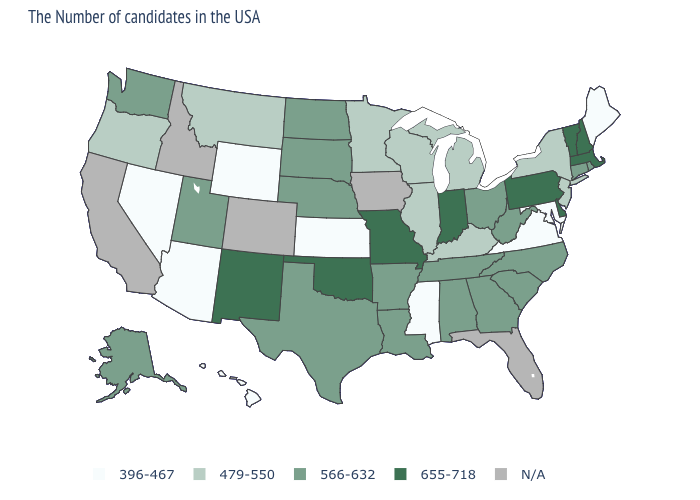What is the value of Maryland?
Write a very short answer. 396-467. What is the lowest value in the USA?
Answer briefly. 396-467. Among the states that border Maine , which have the highest value?
Write a very short answer. New Hampshire. What is the value of Missouri?
Give a very brief answer. 655-718. Name the states that have a value in the range 479-550?
Write a very short answer. New York, New Jersey, Michigan, Kentucky, Wisconsin, Illinois, Minnesota, Montana, Oregon. Name the states that have a value in the range 479-550?
Keep it brief. New York, New Jersey, Michigan, Kentucky, Wisconsin, Illinois, Minnesota, Montana, Oregon. Does Kansas have the highest value in the MidWest?
Be succinct. No. What is the value of Georgia?
Keep it brief. 566-632. What is the lowest value in the West?
Concise answer only. 396-467. Does the map have missing data?
Concise answer only. Yes. Among the states that border Illinois , does Wisconsin have the lowest value?
Quick response, please. Yes. Does Arizona have the lowest value in the USA?
Give a very brief answer. Yes. Name the states that have a value in the range 396-467?
Concise answer only. Maine, Maryland, Virginia, Mississippi, Kansas, Wyoming, Arizona, Nevada, Hawaii. Which states have the lowest value in the USA?
Be succinct. Maine, Maryland, Virginia, Mississippi, Kansas, Wyoming, Arizona, Nevada, Hawaii. 